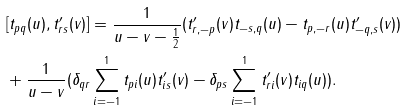Convert formula to latex. <formula><loc_0><loc_0><loc_500><loc_500>& [ t _ { p q } ( u ) , t ^ { \prime } _ { r s } ( v ) ] = \frac { 1 } { u - v - \frac { 1 } { 2 } } ( t ^ { \prime } _ { r , - p } ( v ) t _ { - s , q } ( u ) - t _ { p , - r } ( u ) t ^ { \prime } _ { - q , s } ( v ) ) \\ & + \frac { 1 } { u - v } ( \delta _ { q r } \sum ^ { 1 } _ { i = - 1 } t _ { p i } ( u ) t ^ { \prime } _ { i s } ( v ) - \delta _ { p s } \sum ^ { 1 } _ { i = - 1 } t ^ { \prime } _ { r i } ( v ) t _ { i q } ( u ) ) .</formula> 